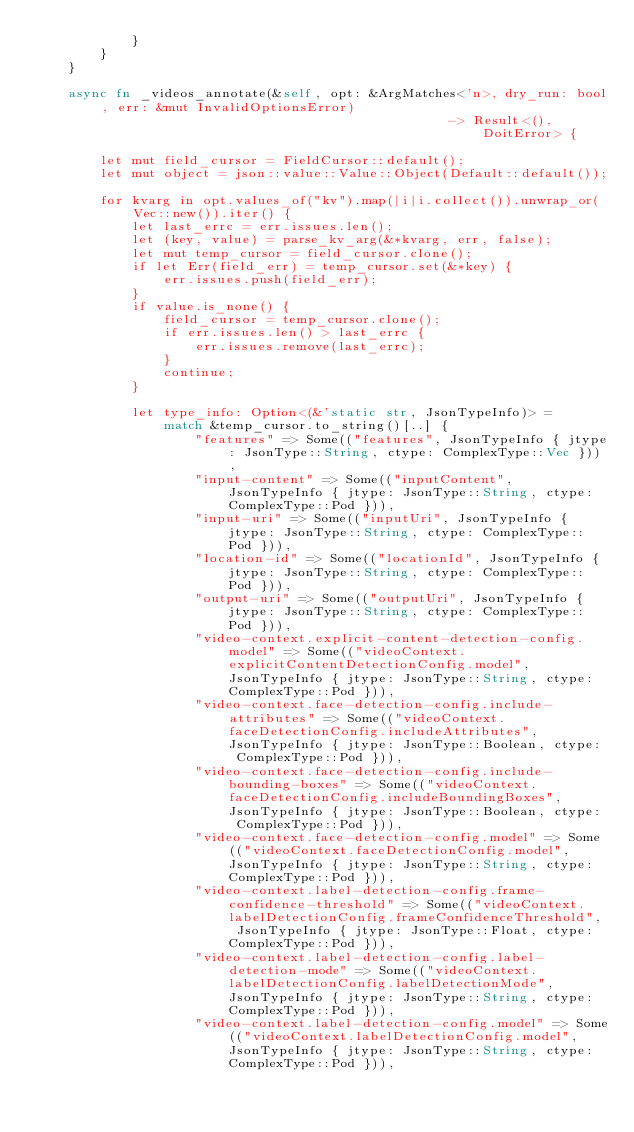Convert code to text. <code><loc_0><loc_0><loc_500><loc_500><_Rust_>            }
        }
    }

    async fn _videos_annotate(&self, opt: &ArgMatches<'n>, dry_run: bool, err: &mut InvalidOptionsError)
                                                    -> Result<(), DoitError> {
        
        let mut field_cursor = FieldCursor::default();
        let mut object = json::value::Value::Object(Default::default());
        
        for kvarg in opt.values_of("kv").map(|i|i.collect()).unwrap_or(Vec::new()).iter() {
            let last_errc = err.issues.len();
            let (key, value) = parse_kv_arg(&*kvarg, err, false);
            let mut temp_cursor = field_cursor.clone();
            if let Err(field_err) = temp_cursor.set(&*key) {
                err.issues.push(field_err);
            }
            if value.is_none() {
                field_cursor = temp_cursor.clone();
                if err.issues.len() > last_errc {
                    err.issues.remove(last_errc);
                }
                continue;
            }
        
            let type_info: Option<(&'static str, JsonTypeInfo)> =
                match &temp_cursor.to_string()[..] {
                    "features" => Some(("features", JsonTypeInfo { jtype: JsonType::String, ctype: ComplexType::Vec })),
                    "input-content" => Some(("inputContent", JsonTypeInfo { jtype: JsonType::String, ctype: ComplexType::Pod })),
                    "input-uri" => Some(("inputUri", JsonTypeInfo { jtype: JsonType::String, ctype: ComplexType::Pod })),
                    "location-id" => Some(("locationId", JsonTypeInfo { jtype: JsonType::String, ctype: ComplexType::Pod })),
                    "output-uri" => Some(("outputUri", JsonTypeInfo { jtype: JsonType::String, ctype: ComplexType::Pod })),
                    "video-context.explicit-content-detection-config.model" => Some(("videoContext.explicitContentDetectionConfig.model", JsonTypeInfo { jtype: JsonType::String, ctype: ComplexType::Pod })),
                    "video-context.face-detection-config.include-attributes" => Some(("videoContext.faceDetectionConfig.includeAttributes", JsonTypeInfo { jtype: JsonType::Boolean, ctype: ComplexType::Pod })),
                    "video-context.face-detection-config.include-bounding-boxes" => Some(("videoContext.faceDetectionConfig.includeBoundingBoxes", JsonTypeInfo { jtype: JsonType::Boolean, ctype: ComplexType::Pod })),
                    "video-context.face-detection-config.model" => Some(("videoContext.faceDetectionConfig.model", JsonTypeInfo { jtype: JsonType::String, ctype: ComplexType::Pod })),
                    "video-context.label-detection-config.frame-confidence-threshold" => Some(("videoContext.labelDetectionConfig.frameConfidenceThreshold", JsonTypeInfo { jtype: JsonType::Float, ctype: ComplexType::Pod })),
                    "video-context.label-detection-config.label-detection-mode" => Some(("videoContext.labelDetectionConfig.labelDetectionMode", JsonTypeInfo { jtype: JsonType::String, ctype: ComplexType::Pod })),
                    "video-context.label-detection-config.model" => Some(("videoContext.labelDetectionConfig.model", JsonTypeInfo { jtype: JsonType::String, ctype: ComplexType::Pod })),</code> 